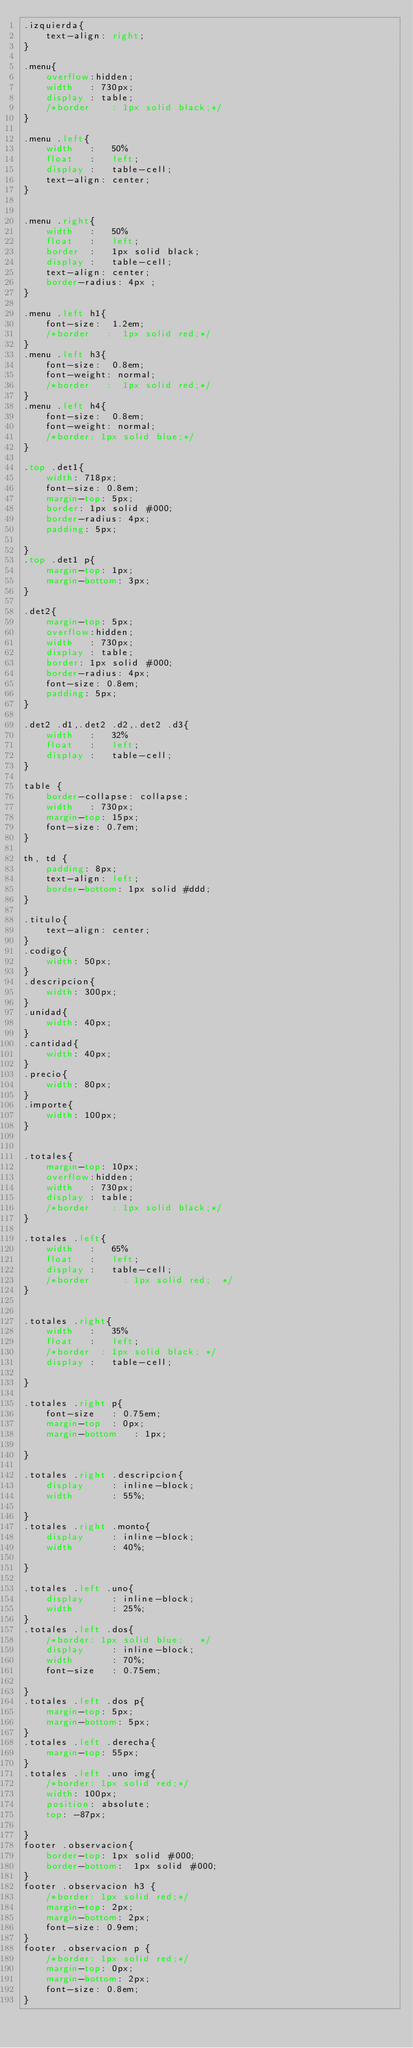Convert code to text. <code><loc_0><loc_0><loc_500><loc_500><_CSS_>.izquierda{
	text-align: right;
}

.menu{
    overflow:hidden;
    width 	: 730px;
    display : table;
    /*border 	: 1px solid black;*/
}

.menu .left{
    width	: 	50%
    float	:	left;
    display : 	table-cell; 
    text-align: center;     
}


.menu .right{
    width	: 	50%
    float	:	left;
    border  :	1px solid black; 
    display : 	table-cell; 
    text-align: center; 
    border-radius: 4px ;    
}

.menu .left h1{
	font-size:  1.2em;
	/*border   :  1px solid red;*/
}
.menu .left h3{
	font-size:  0.8em;
	font-weight: normal;
	/*border   :  1px solid red;*/
}
.menu .left h4{
	font-size:  0.8em;
	font-weight: normal;	
	/*border: 1px solid blue;*/
}

.top .det1{
	width: 718px;
	font-size: 0.8em;
	margin-top: 5px;
	border: 1px solid #000;
	border-radius: 4px;
	padding: 5px;

}
.top .det1 p{
	margin-top: 1px;
	margin-bottom: 3px;
}

.det2{
	margin-top: 5px;
    overflow:hidden;
    width 	: 730px;
    display : table;
	border: 1px solid #000;
	border-radius: 4px;
    font-size: 0.8em;
    padding: 5px;
}

.det2 .d1,.det2 .d2,.det2 .d3{
    width	: 	32%
    float	:	left;
    display : 	table-cell;     
}

table {
    border-collapse: collapse;
    width 	: 730px;
	margin-top: 15px;
    font-size: 0.7em;    
}

th, td {
    padding: 8px;
    text-align: left;
    border-bottom: 1px solid #ddd;
}

.titulo{
	text-align: center;
}
.codigo{
	width: 50px;
}
.descripcion{
	width: 300px;
}
.unidad{
	width: 40px;
}
.cantidad{
	width: 40px;
}
.precio{
	width: 80px;
}
.importe{
	width: 100px;
}


.totales{
	margin-top: 10px;
    overflow:hidden;
    width 	: 730px;
    display : table;
    /*border 	: 1px solid black;*/
}

.totales .left{
    width	: 	65%
    float	:	left;
    display : 	table-cell;  
   	/*border      : 1px solid red;  */ 
}


.totales .right{
    width	: 	35%
    float	:	left;
    /*border  :	1px solid black; */
    display : 	table-cell; 
      
}

.totales .right p{
	font-size 	: 0.75em;
	margin-top	: 0px;
	margin-bottom 	: 1px;	

}

.totales .right .descripcion{
	display 	: inline-block;
	width 		: 55%;

}
.totales .right .monto{
	display 	: inline-block;
	width 		: 40%;

}

.totales .left .uno{
    display     : inline-block;
    width       : 25%;
}
.totales .left .dos{
    /*border: 1px solid blue;   */ 
    display     : inline-block;
    width       : 70%;
    font-size   : 0.75em;

}
.totales .left .dos p{
    margin-top: 5px;
    margin-bottom: 5px;
}
.totales .left .derecha{
    margin-top: 55px;
}
.totales .left .uno img{
    /*border: 1px solid red;*/
    width: 100px;
    position: absolute;
    top: -87px;

}
footer .observacion{
    border-top: 1px solid #000;
    border-bottom:  1px solid #000;
}
footer .observacion h3 {
    /*border: 1px solid red;*/
    margin-top: 2px;
    margin-bottom: 2px;
    font-size: 0.9em;
}
footer .observacion p {
    /*border: 1px solid red;*/
    margin-top: 0px;
    margin-bottom: 2px;    
    font-size: 0.8em;
}
</code> 